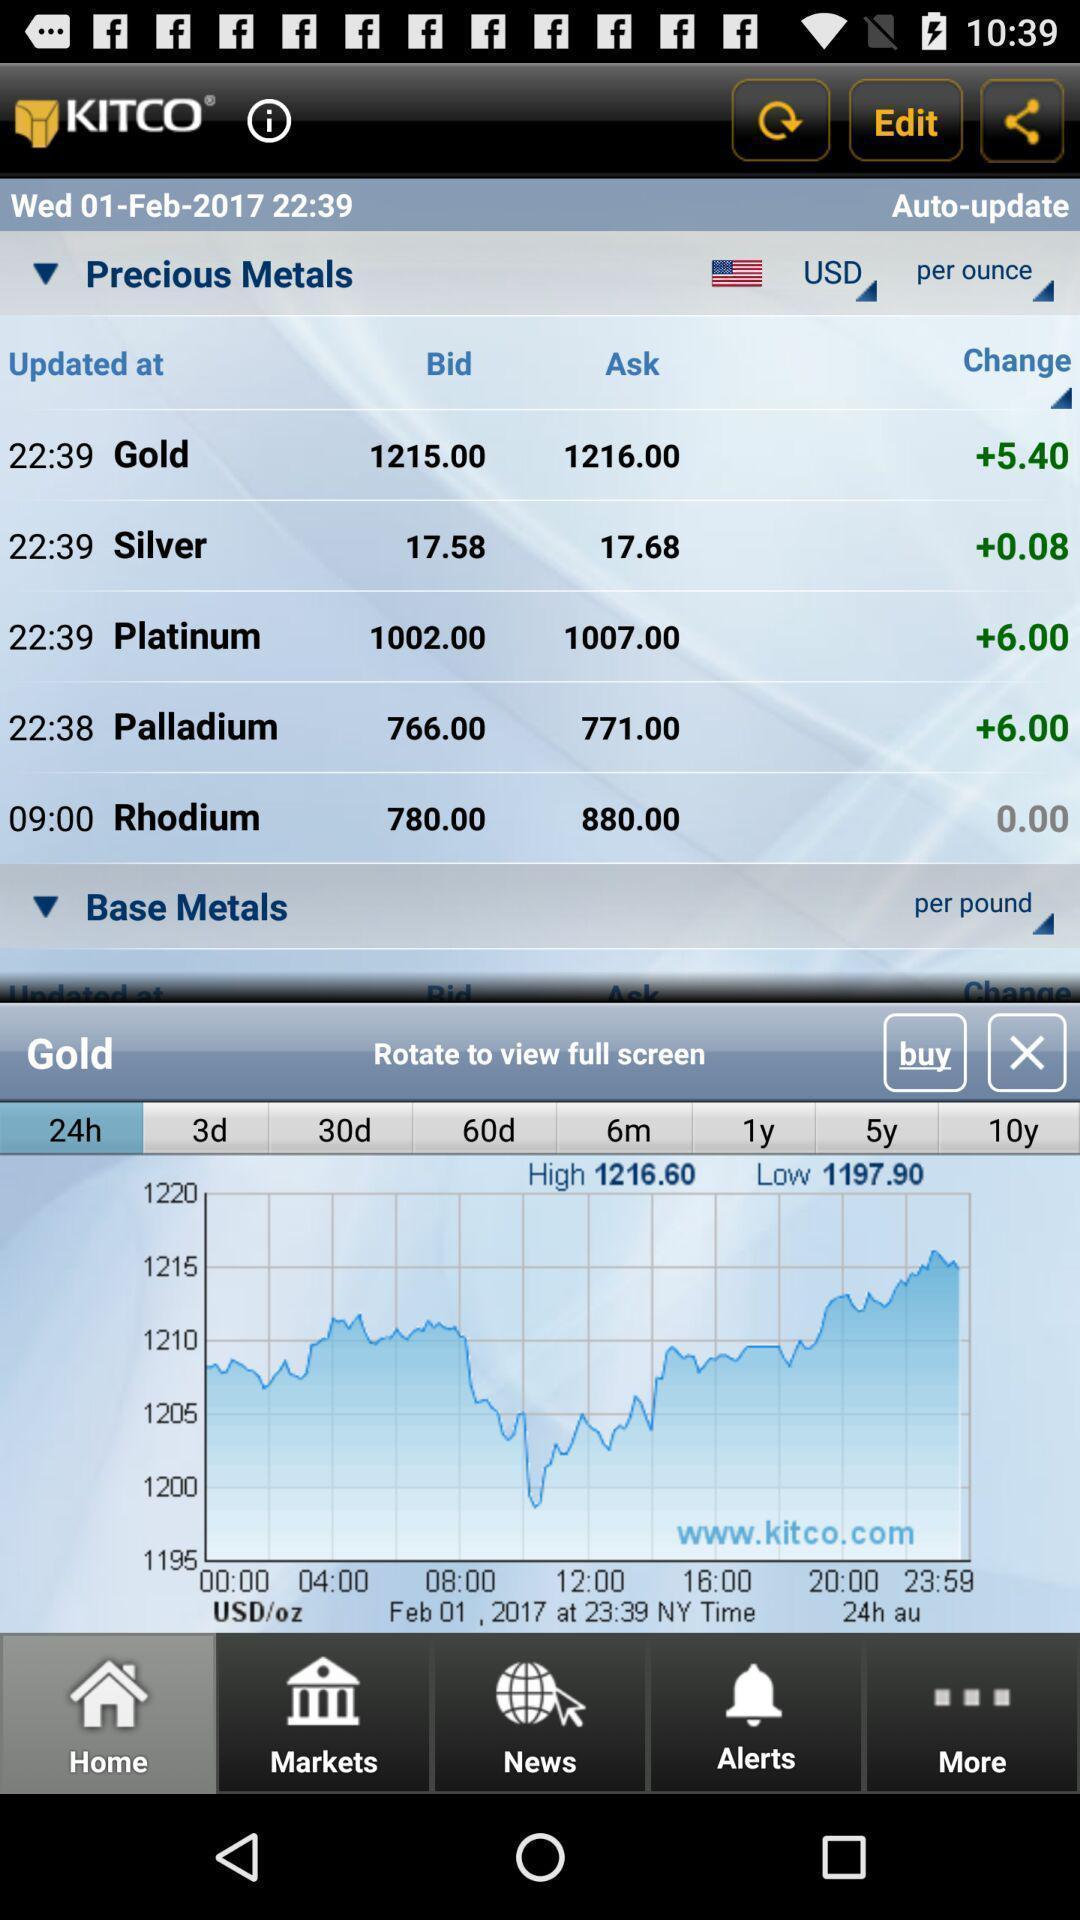Summarize the information in this screenshot. Updated base metals in precious metals. 